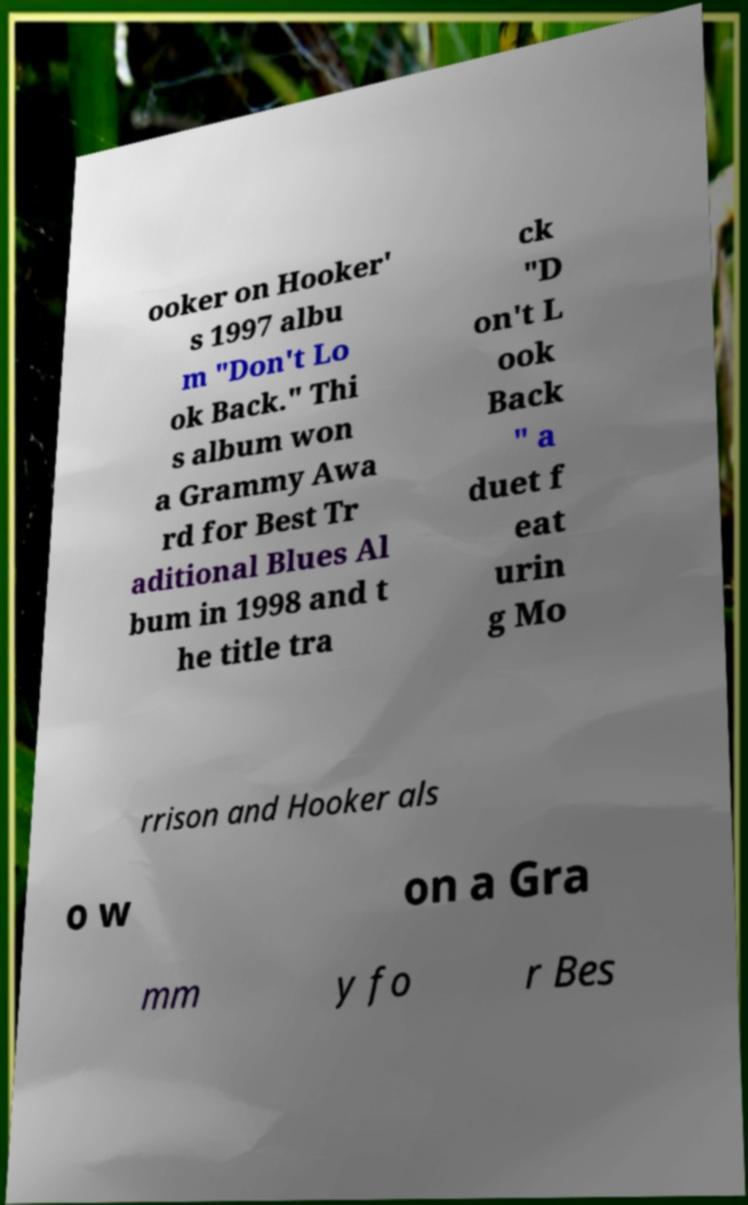I need the written content from this picture converted into text. Can you do that? ooker on Hooker' s 1997 albu m "Don't Lo ok Back." Thi s album won a Grammy Awa rd for Best Tr aditional Blues Al bum in 1998 and t he title tra ck "D on't L ook Back " a duet f eat urin g Mo rrison and Hooker als o w on a Gra mm y fo r Bes 